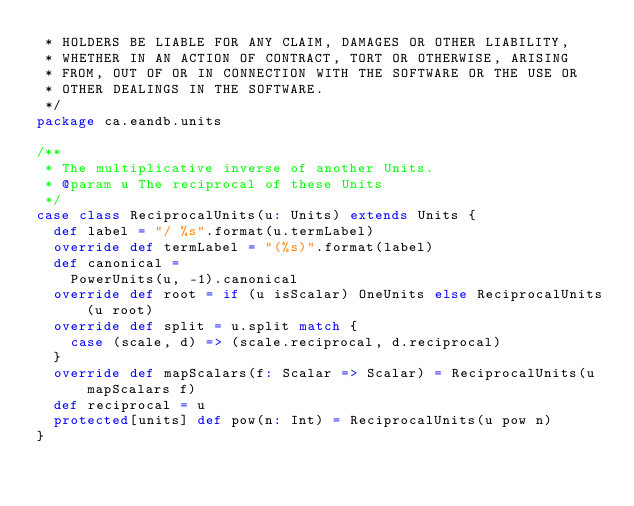Convert code to text. <code><loc_0><loc_0><loc_500><loc_500><_Scala_> * HOLDERS BE LIABLE FOR ANY CLAIM, DAMAGES OR OTHER LIABILITY,
 * WHETHER IN AN ACTION OF CONTRACT, TORT OR OTHERWISE, ARISING
 * FROM, OUT OF OR IN CONNECTION WITH THE SOFTWARE OR THE USE OR
 * OTHER DEALINGS IN THE SOFTWARE.
 */
package ca.eandb.units

/**
 * The multiplicative inverse of another Units.
 * @param u The reciprocal of these Units
 */
case class ReciprocalUnits(u: Units) extends Units {
  def label = "/ %s".format(u.termLabel)
  override def termLabel = "(%s)".format(label)
  def canonical =
    PowerUnits(u, -1).canonical
  override def root = if (u isScalar) OneUnits else ReciprocalUnits(u root)
  override def split = u.split match {
    case (scale, d) => (scale.reciprocal, d.reciprocal)
  }
  override def mapScalars(f: Scalar => Scalar) = ReciprocalUnits(u mapScalars f)
  def reciprocal = u
  protected[units] def pow(n: Int) = ReciprocalUnits(u pow n)
}

</code> 